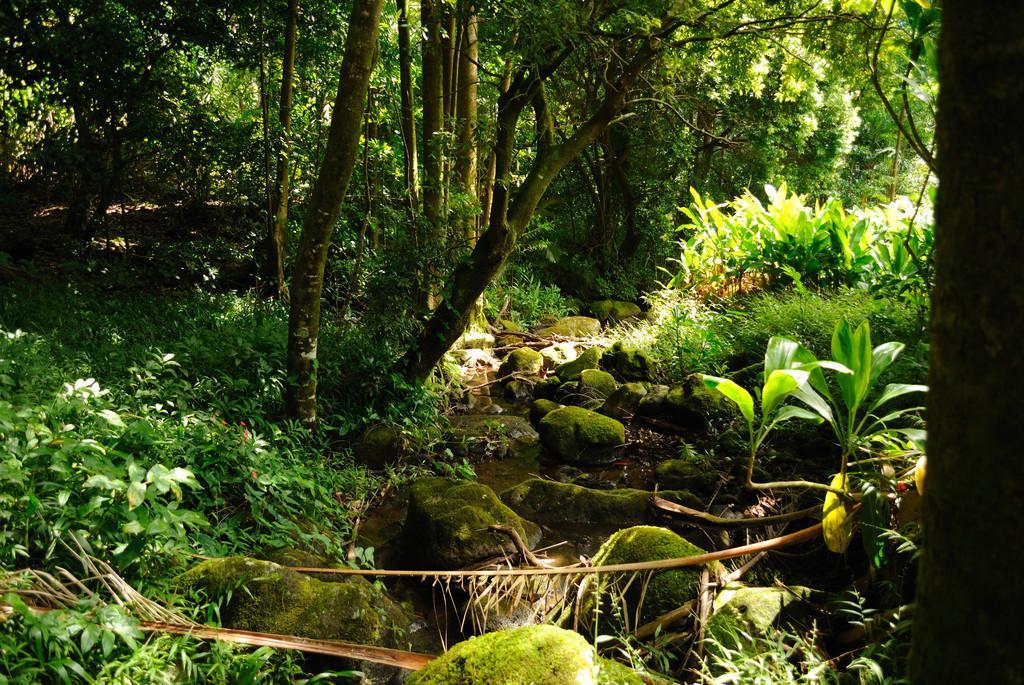How would you summarize this image in a sentence or two? At the bottom of the picture, we see rocks and trees. There are trees in the background. This picture might be clicked in the forest. 